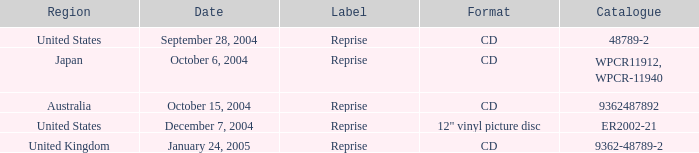What is the catalogue on october 15, 2004? 9362487892.0. 